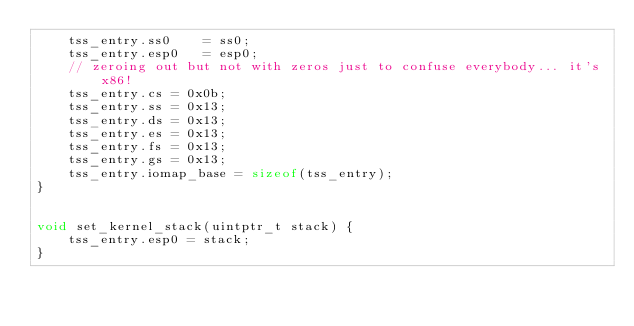Convert code to text. <code><loc_0><loc_0><loc_500><loc_500><_C_>	tss_entry.ss0    = ss0;
	tss_entry.esp0   = esp0;
	// zeroing out but not with zeros just to confuse everybody... it's x86!
	tss_entry.cs = 0x0b;
	tss_entry.ss = 0x13;
	tss_entry.ds = 0x13;
	tss_entry.es = 0x13;
	tss_entry.fs = 0x13;
	tss_entry.gs = 0x13;
	tss_entry.iomap_base = sizeof(tss_entry);
}


void set_kernel_stack(uintptr_t stack) {
	tss_entry.esp0 = stack;
}
</code> 